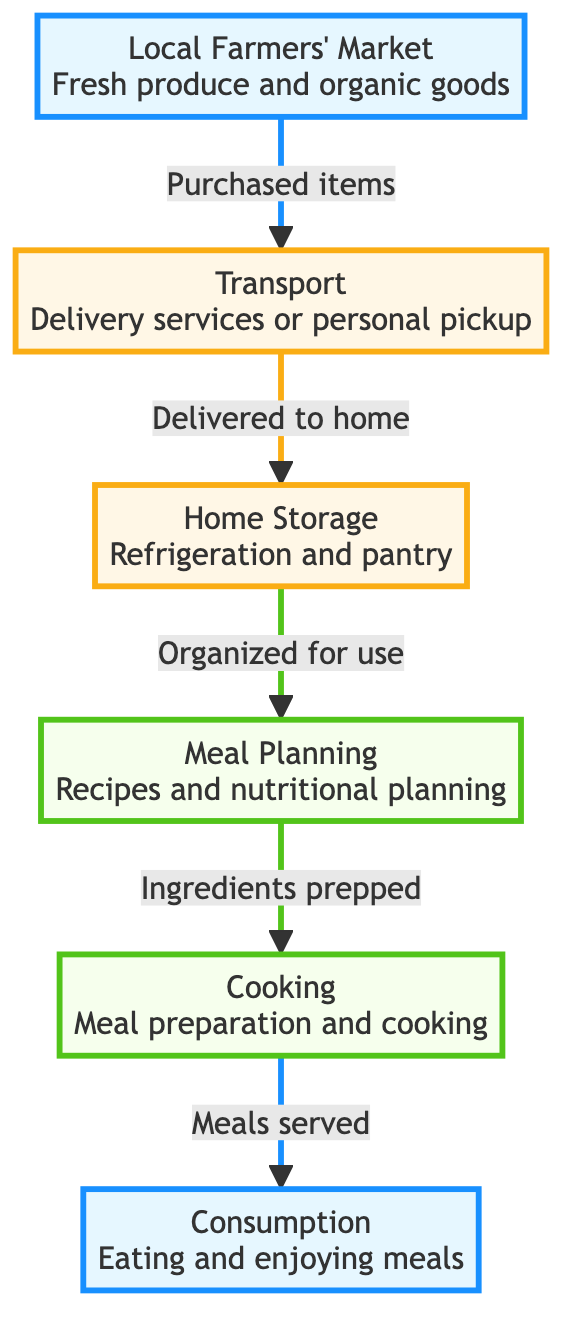What is the first step in the food chain? The diagram indicates that the first step is 'Local Farmers' Market', which includes fresh produce and organic goods.
Answer: Local Farmers' Market How many main nodes are there in the diagram? By counting the nodes, we find there are a total of six main nodes represented in the diagram.
Answer: Six What does the arrow from 'Home Storage' to 'Meal Planning' represent? The arrow indicates that after storing food at home, it is organized for use in meal planning.
Answer: Organized for use What is transported after being purchased at the local farmers' market? The diagram shows that 'Fresh produce and organic goods' are transported after being purchased.
Answer: Fresh produce and organic goods Which node directly follows 'Cooking'? The node that directly follows 'Cooking' is 'Consumption', indicating the next step after meal preparation.
Answer: Consumption What type of planning follows 'Home Storage'? The diagram indicates that 'Meal Planning' follows 'Home Storage', showcasing the flow of organization leading to meal preparation.
Answer: Meal Planning What services can be used for the transport step? The transport step can involve either 'Delivery services' or 'personal pickup', as indicated in the diagram.
Answer: Delivery services or personal pickup What is the last step of the food chain? The last step in the flow of the food chain as presented in the diagram is 'Consumption', which refers to eating and enjoying meals.
Answer: Consumption What is the relationship between 'Cooking' and 'Consumption'? The relationship as indicated by the arrow shows that meals are served after the cooking step, leading to consumption.
Answer: Meals served 